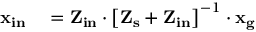Convert formula to latex. <formula><loc_0><loc_0><loc_500><loc_500>\begin{array} { r l } { x _ { i n } } & = Z _ { i n } \cdot \left [ Z _ { s } + Z _ { i n } \right ] ^ { - 1 } \cdot x _ { g } } \end{array}</formula> 